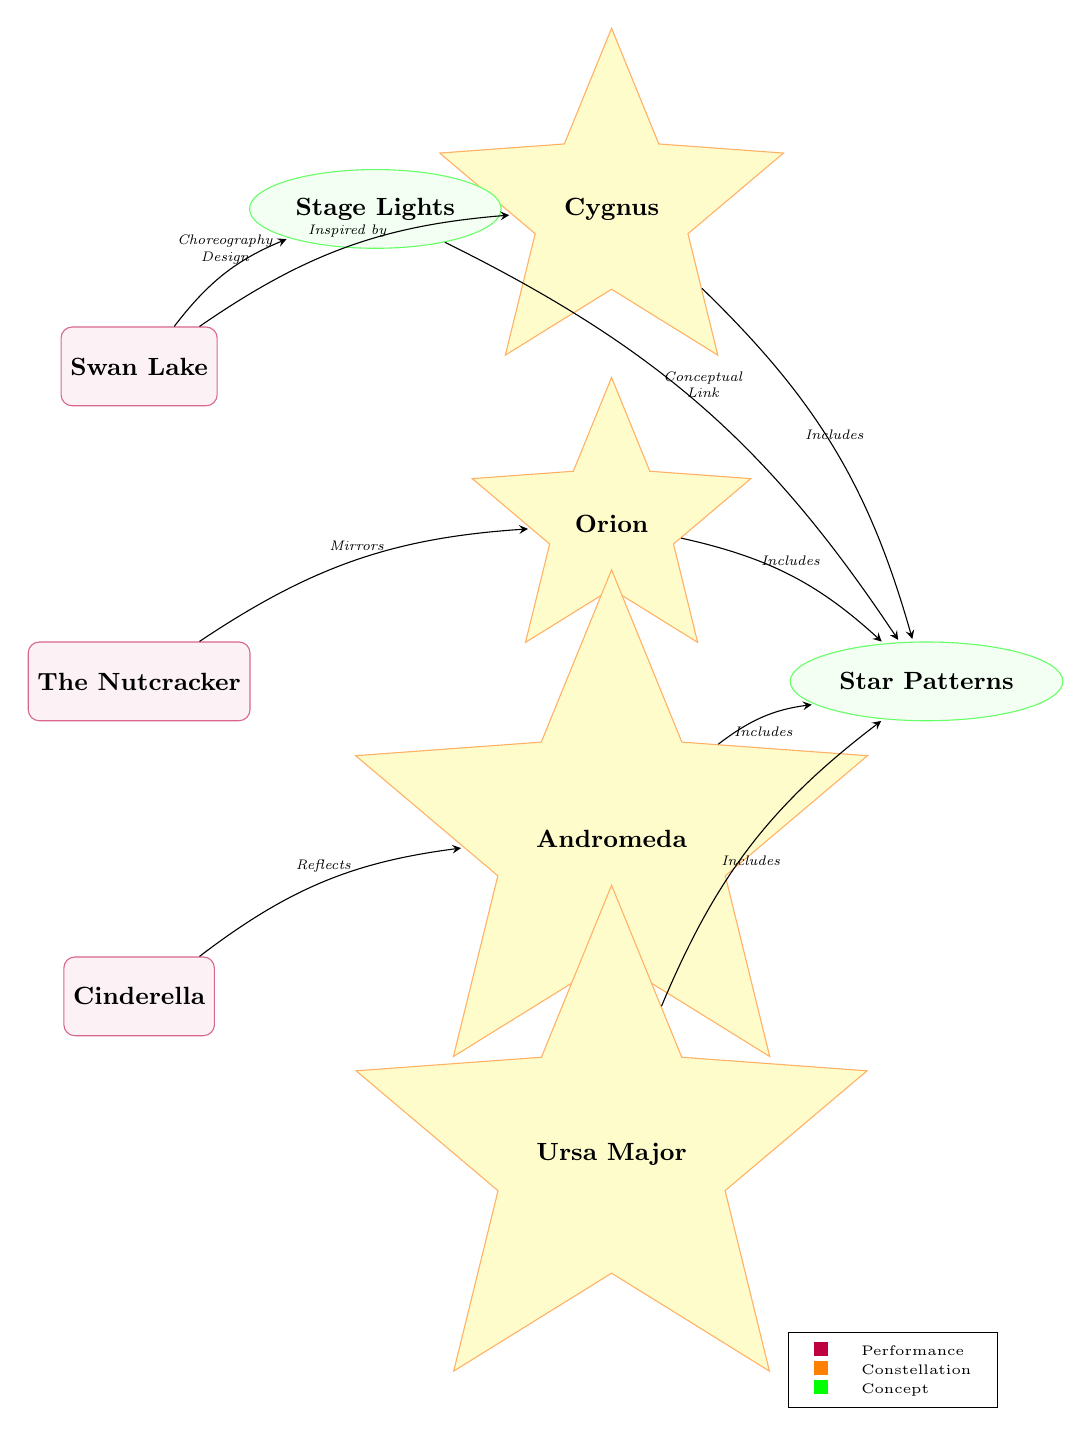What ballet performance is linked to the constellation Cygnus? The diagram shows an edge connecting the node "Swan Lake" to the node "Cygnus" with the label "Inspired by," indicating that "Swan Lake" is related to "Cygnus."
Answer: Swan Lake How many constellations are depicted in the diagram? The diagram displays four constellation nodes: Orion, Andromeda, Ursa Major, and Cygnus. Counting these nodes gives a total of four constellations.
Answer: 4 What type of relationship does "Nutcracker" have with "Orion"? The diagram shows an arrow (edge) from the node "Nutcracker" to the node "Orion," labeled "Mirrors." This indicates that "Nutcracker" has a mirroring relationship with "Orion."
Answer: Mirrors Which ballet performance reflects the constellation Andromeda? The edge from "Cinderella" to "Andromeda," labeled "Reflects," shows that "Cinderella" is the ballet performance that reflects "Andromeda."
Answer: Cinderella Which concept serves as a link between stage lights and star patterns? The diagram indicates an edge from "Stage Lights" to "Star Patterns" with the label "Conceptual Link." This describes the connection between these two concepts.
Answer: Conceptual Link What is the relationship between the constellation Ursa Major and star patterns? The diagram shows an edge from "Ursa Major" to "Star Patterns," labeled "Includes," indicating that "Ursa Major" is included in the star patterns.
Answer: Includes Which performance is described as having a choreography design linked to stage lights? The edge from "Swan Lake" to "Stage Lights" shows the label "Choreography Design," which indicates that this performance has a direct link related to the stage lights through its choreography.
Answer: Swan Lake How many performances are represented in the diagram? There are three performance nodes in the diagram: Swan Lake, Nutcracker, and Cinderella. Counting these nodes results in a total of three performances.
Answer: 3 